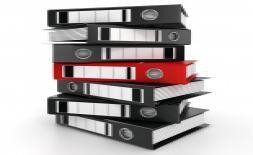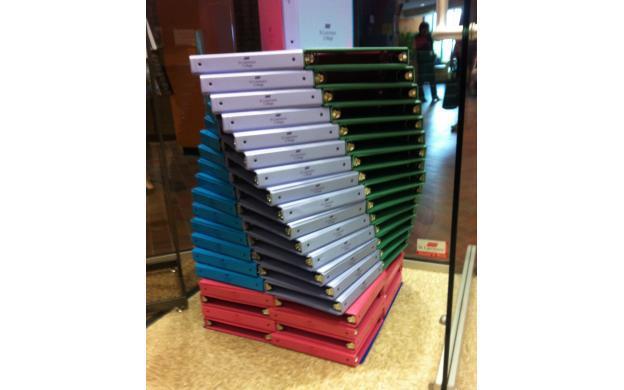The first image is the image on the left, the second image is the image on the right. Analyze the images presented: Is the assertion "In one image, no more than five notebooks filled with paper contents are stacked with ring ends on alternating sides, while a second image shows similar notebooks and contents in a larger stack." valid? Answer yes or no. No. The first image is the image on the left, the second image is the image on the right. Analyze the images presented: Is the assertion "An image contains no more than five binders, which are stacked alternately, front to back." valid? Answer yes or no. No. 